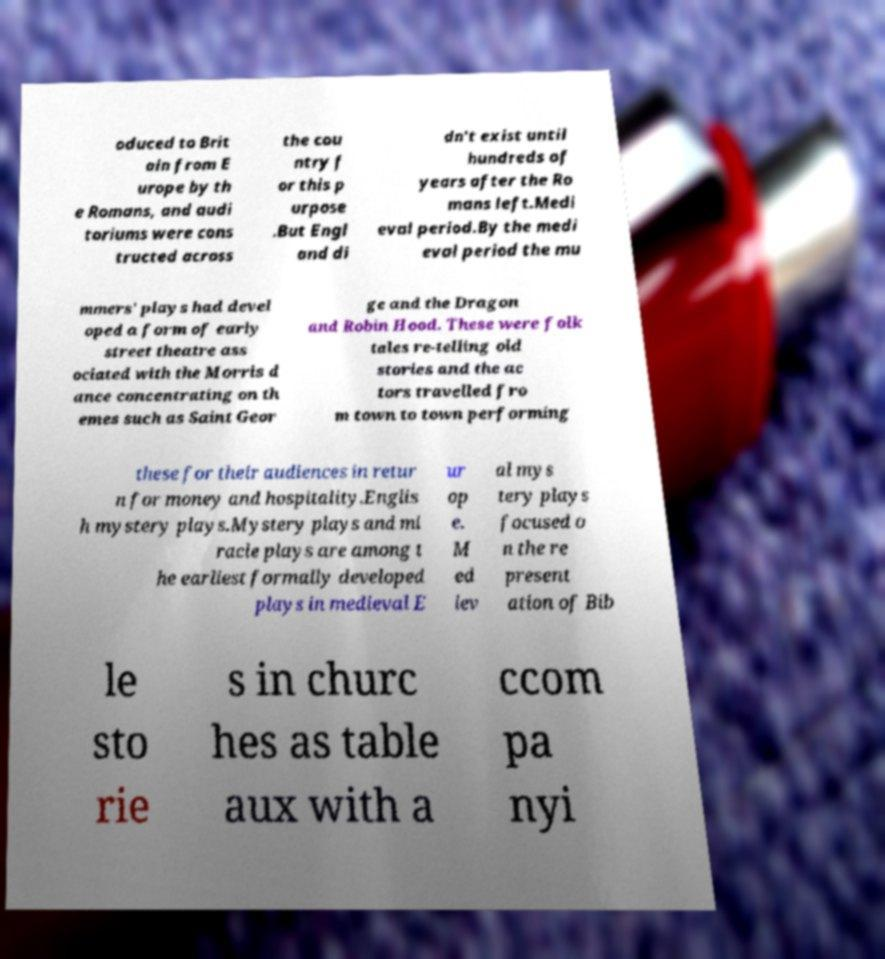Could you assist in decoding the text presented in this image and type it out clearly? oduced to Brit ain from E urope by th e Romans, and audi toriums were cons tructed across the cou ntry f or this p urpose .But Engl and di dn't exist until hundreds of years after the Ro mans left.Medi eval period.By the medi eval period the mu mmers' plays had devel oped a form of early street theatre ass ociated with the Morris d ance concentrating on th emes such as Saint Geor ge and the Dragon and Robin Hood. These were folk tales re-telling old stories and the ac tors travelled fro m town to town performing these for their audiences in retur n for money and hospitality.Englis h mystery plays.Mystery plays and mi racle plays are among t he earliest formally developed plays in medieval E ur op e. M ed iev al mys tery plays focused o n the re present ation of Bib le sto rie s in churc hes as table aux with a ccom pa nyi 